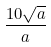<formula> <loc_0><loc_0><loc_500><loc_500>\frac { 1 0 \sqrt { a } } { a }</formula> 